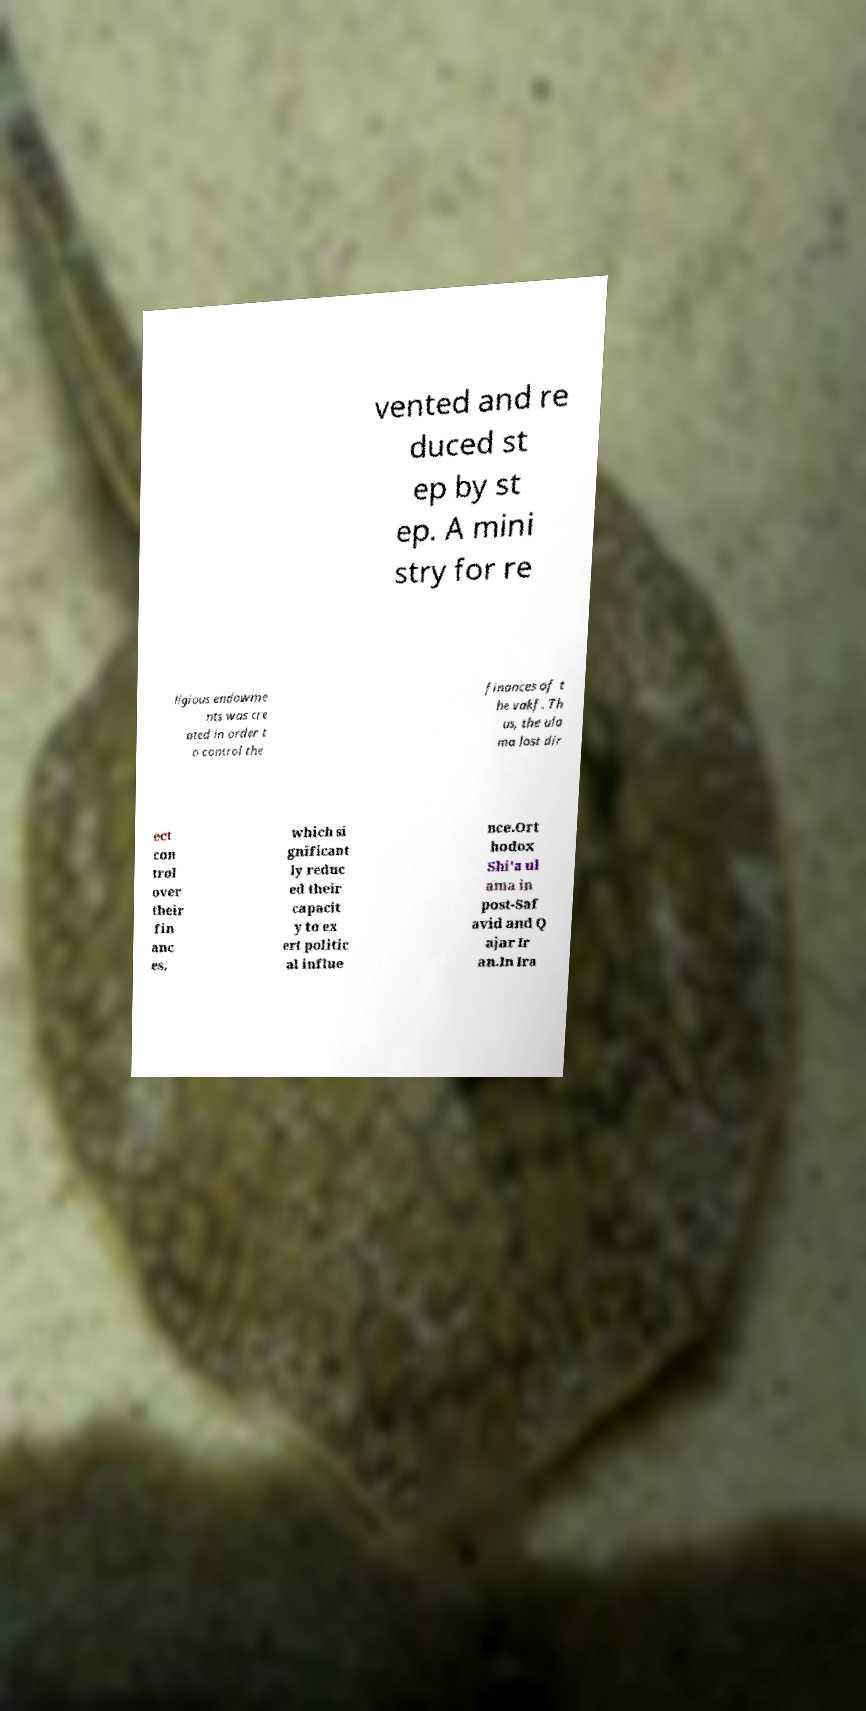For documentation purposes, I need the text within this image transcribed. Could you provide that? vented and re duced st ep by st ep. A mini stry for re ligious endowme nts was cre ated in order t o control the finances of t he vakf. Th us, the ula ma lost dir ect con trol over their fin anc es, which si gnificant ly reduc ed their capacit y to ex ert politic al influe nce.Ort hodox Shi'a ul ama in post-Saf avid and Q ajar Ir an.In Ira 